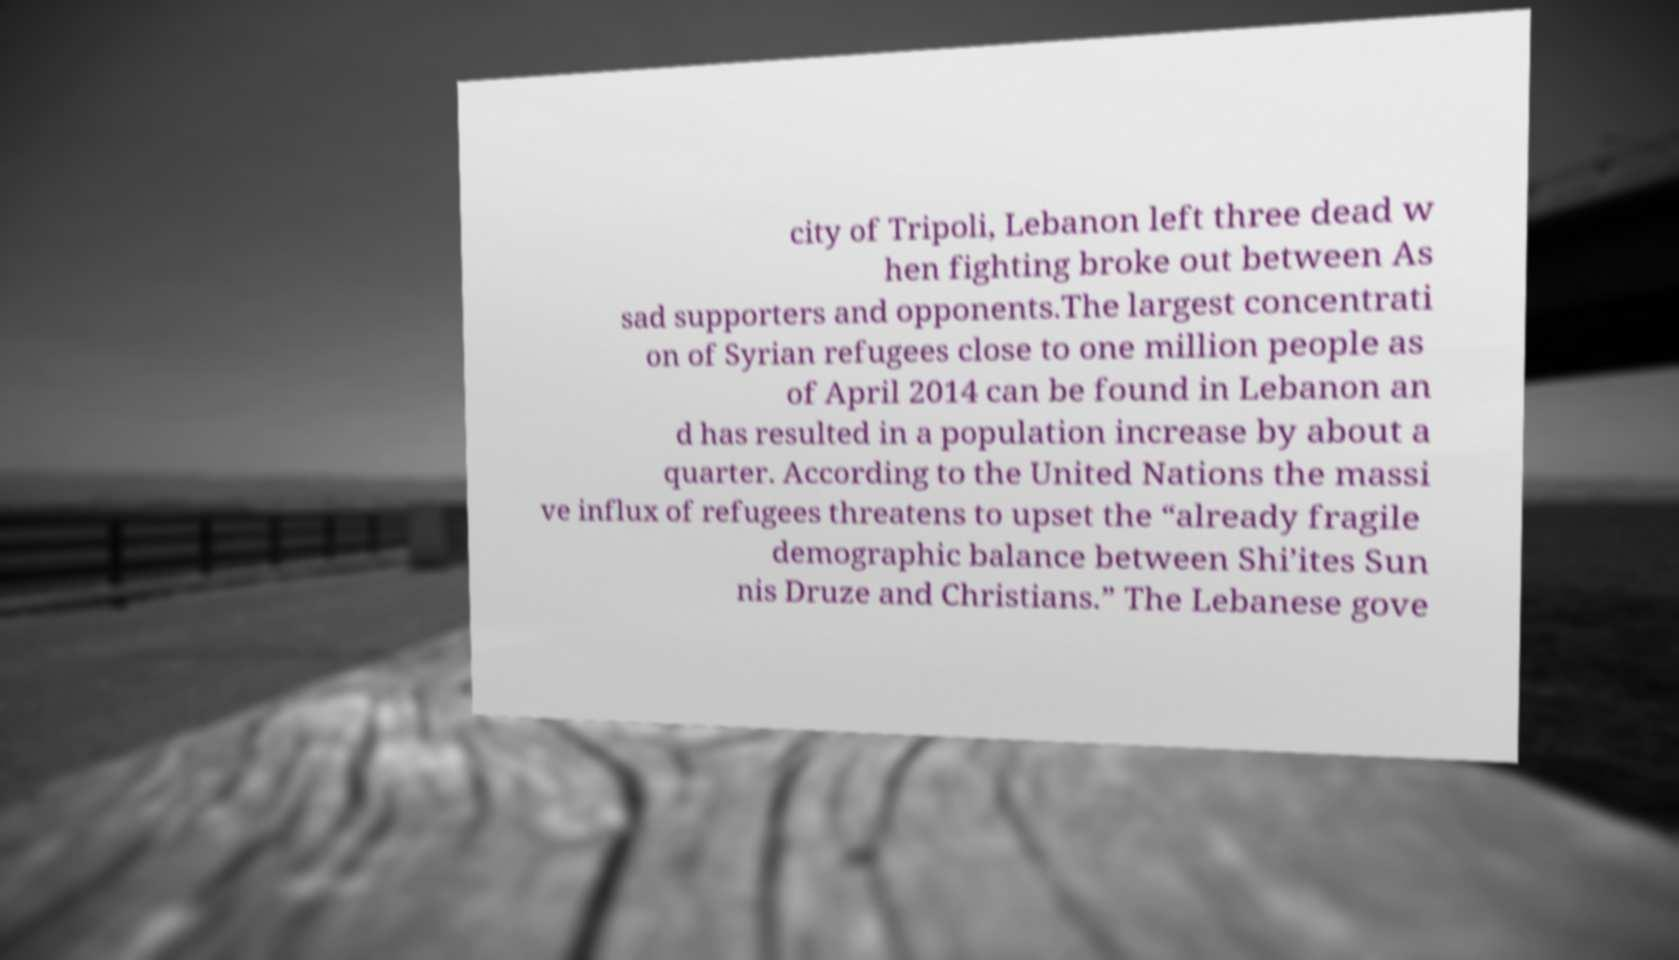Could you extract and type out the text from this image? city of Tripoli, Lebanon left three dead w hen fighting broke out between As sad supporters and opponents.The largest concentrati on of Syrian refugees close to one million people as of April 2014 can be found in Lebanon an d has resulted in a population increase by about a quarter. According to the United Nations the massi ve influx of refugees threatens to upset the “already fragile demographic balance between Shi’ites Sun nis Druze and Christians.” The Lebanese gove 